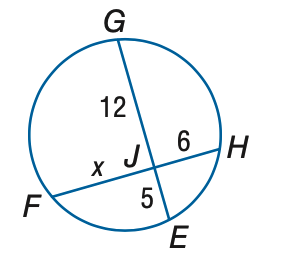Question: Find x to the nearest tenth.
Choices:
A. 7
B. 8
C. 9
D. 10
Answer with the letter. Answer: D 